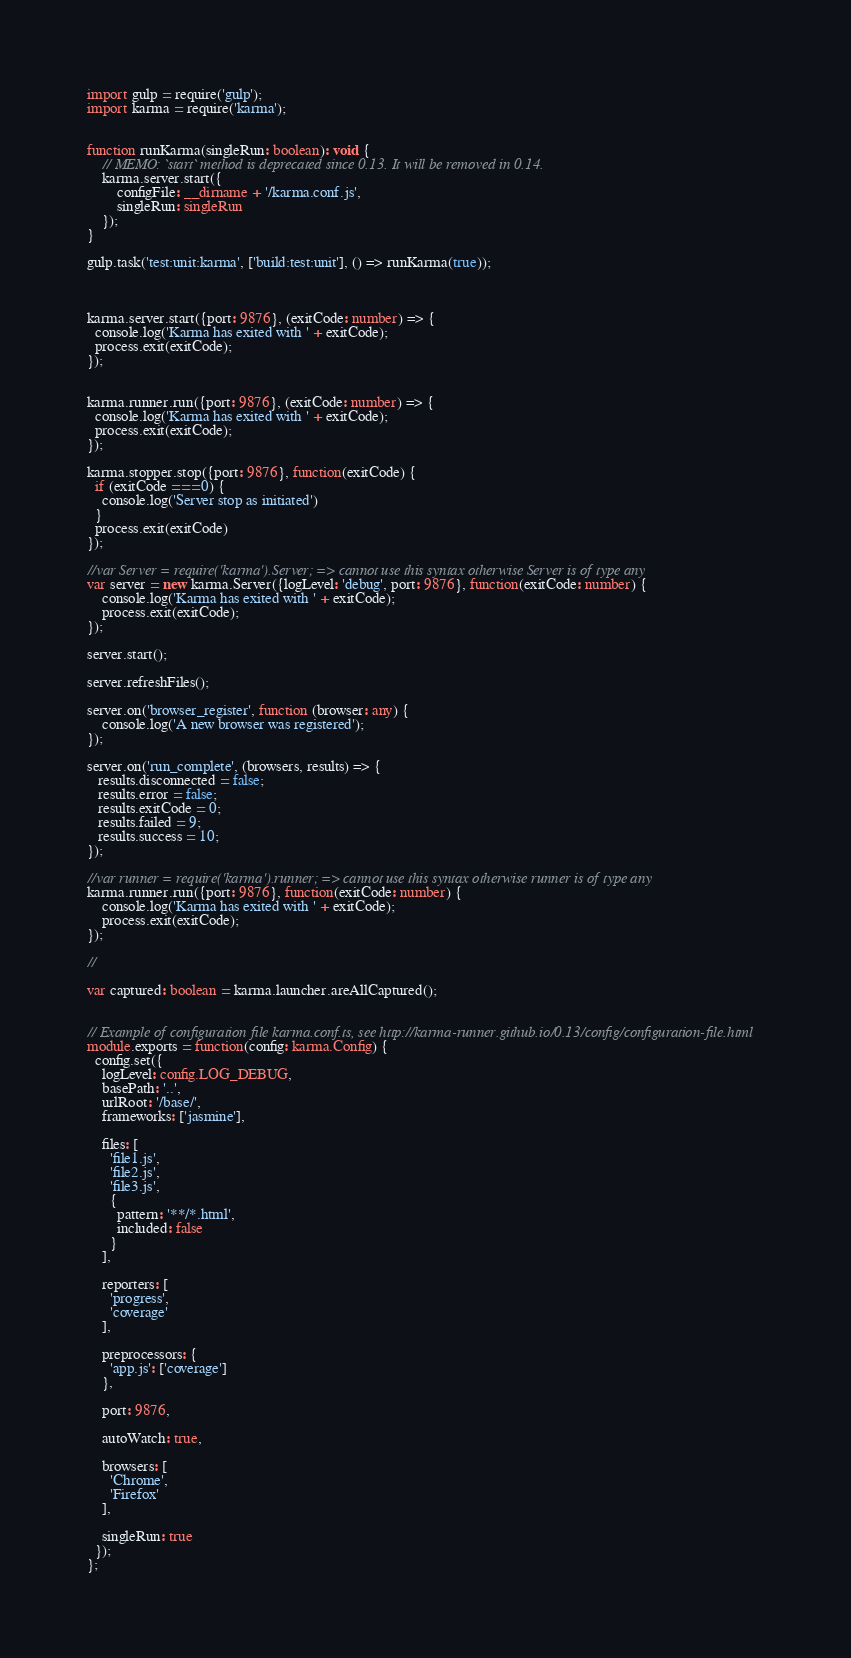Convert code to text. <code><loc_0><loc_0><loc_500><loc_500><_TypeScript_>


import gulp = require('gulp');
import karma = require('karma');


function runKarma(singleRun: boolean): void {
    // MEMO: `start` method is deprecated since 0.13. It will be removed in 0.14.
    karma.server.start({
        configFile: __dirname + '/karma.conf.js',
        singleRun: singleRun
    });
}

gulp.task('test:unit:karma', ['build:test:unit'], () => runKarma(true));



karma.server.start({port: 9876}, (exitCode: number) => {
  console.log('Karma has exited with ' + exitCode);
  process.exit(exitCode);
});


karma.runner.run({port: 9876}, (exitCode: number) => {
  console.log('Karma has exited with ' + exitCode);
  process.exit(exitCode);
});

karma.stopper.stop({port: 9876}, function(exitCode) {
  if (exitCode === 0) {
    console.log('Server stop as initiated')
  }
  process.exit(exitCode)
});

//var Server = require('karma').Server; => cannot use this syntax otherwise Server is of type any
var server = new karma.Server({logLevel: 'debug', port: 9876}, function(exitCode: number) {
    console.log('Karma has exited with ' + exitCode);
    process.exit(exitCode);
});

server.start();

server.refreshFiles();

server.on('browser_register', function (browser: any) {
    console.log('A new browser was registered');
});

server.on('run_complete', (browsers, results) => {
   results.disconnected = false;
   results.error = false;
   results.exitCode = 0;
   results.failed = 9;
   results.success = 10; 
});

//var runner = require('karma').runner; => cannot use this syntax otherwise runner is of type any
karma.runner.run({port: 9876}, function(exitCode: number) {
    console.log('Karma has exited with ' + exitCode);
    process.exit(exitCode);
});

//

var captured: boolean = karma.launcher.areAllCaptured();


// Example of configuration file karma.conf.ts, see http://karma-runner.github.io/0.13/config/configuration-file.html
module.exports = function(config: karma.Config) {
  config.set({
    logLevel: config.LOG_DEBUG,
    basePath: '..',
    urlRoot: '/base/',
    frameworks: ['jasmine'],

    files: [
      'file1.js',
      'file2.js',
      'file3.js',
      {
        pattern: '**/*.html',
        included: false
      }
    ],

    reporters: [
      'progress',
      'coverage'
    ],

    preprocessors: {
      'app.js': ['coverage']
    },

    port: 9876,

    autoWatch: true,

    browsers: [
      'Chrome',
      'Firefox'
    ],

    singleRun: true
  });
};
</code> 